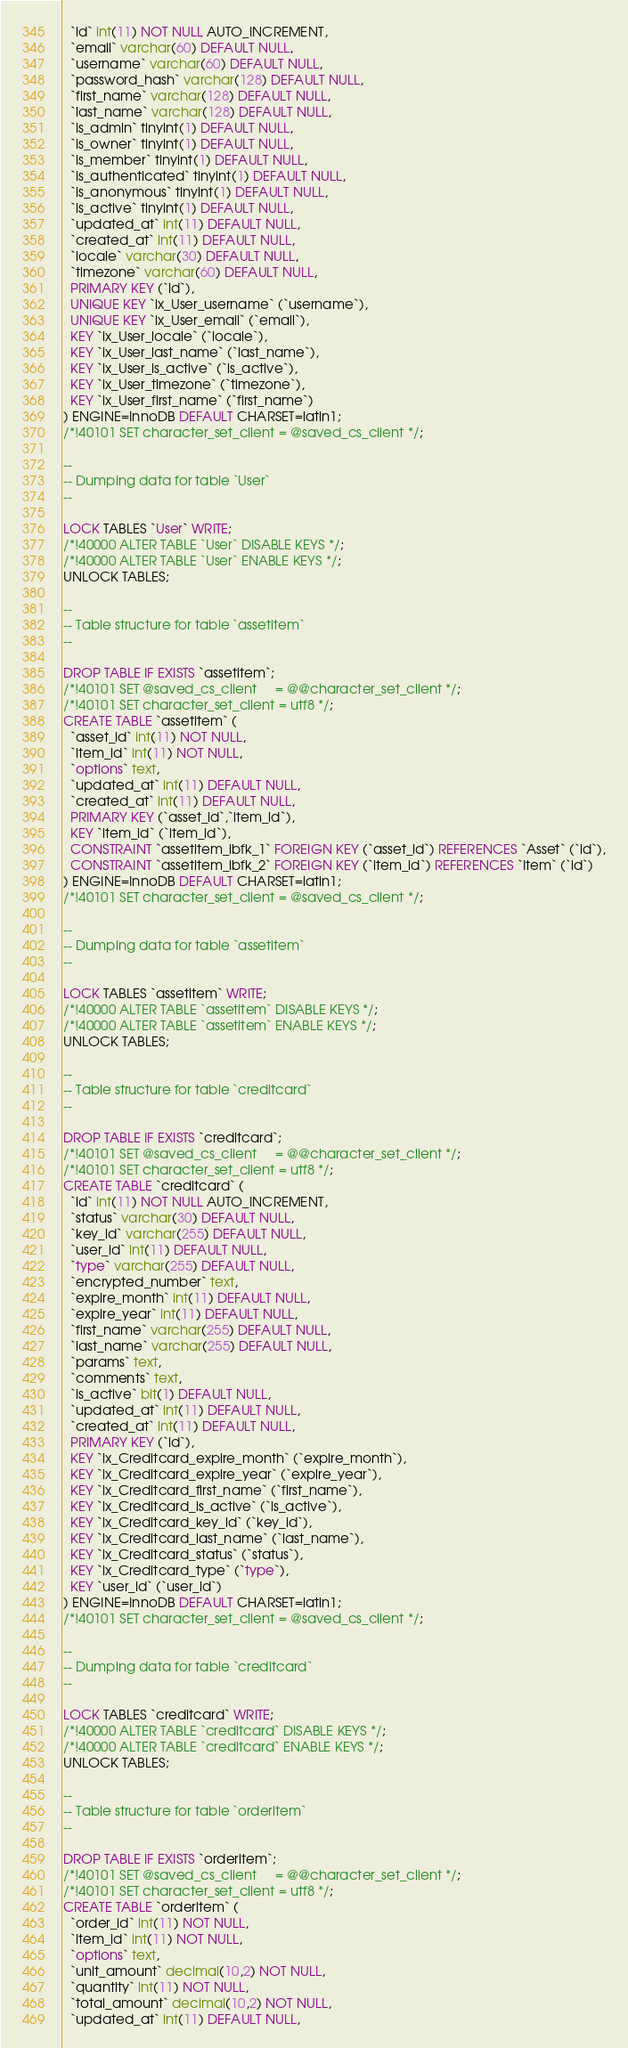Convert code to text. <code><loc_0><loc_0><loc_500><loc_500><_SQL_>  `id` int(11) NOT NULL AUTO_INCREMENT,
  `email` varchar(60) DEFAULT NULL,
  `username` varchar(60) DEFAULT NULL,
  `password_hash` varchar(128) DEFAULT NULL,
  `first_name` varchar(128) DEFAULT NULL,
  `last_name` varchar(128) DEFAULT NULL,
  `is_admin` tinyint(1) DEFAULT NULL,
  `is_owner` tinyint(1) DEFAULT NULL,
  `is_member` tinyint(1) DEFAULT NULL,
  `is_authenticated` tinyint(1) DEFAULT NULL,
  `is_anonymous` tinyint(1) DEFAULT NULL,
  `is_active` tinyint(1) DEFAULT NULL,
  `updated_at` int(11) DEFAULT NULL,
  `created_at` int(11) DEFAULT NULL,
  `locale` varchar(30) DEFAULT NULL,
  `timezone` varchar(60) DEFAULT NULL,
  PRIMARY KEY (`id`),
  UNIQUE KEY `ix_User_username` (`username`),
  UNIQUE KEY `ix_User_email` (`email`),
  KEY `ix_User_locale` (`locale`),
  KEY `ix_User_last_name` (`last_name`),
  KEY `ix_User_is_active` (`is_active`),
  KEY `ix_User_timezone` (`timezone`),
  KEY `ix_User_first_name` (`first_name`)
) ENGINE=InnoDB DEFAULT CHARSET=latin1;
/*!40101 SET character_set_client = @saved_cs_client */;

--
-- Dumping data for table `User`
--

LOCK TABLES `User` WRITE;
/*!40000 ALTER TABLE `User` DISABLE KEYS */;
/*!40000 ALTER TABLE `User` ENABLE KEYS */;
UNLOCK TABLES;

--
-- Table structure for table `assetitem`
--

DROP TABLE IF EXISTS `assetitem`;
/*!40101 SET @saved_cs_client     = @@character_set_client */;
/*!40101 SET character_set_client = utf8 */;
CREATE TABLE `assetitem` (
  `asset_id` int(11) NOT NULL,
  `item_id` int(11) NOT NULL,
  `options` text,
  `updated_at` int(11) DEFAULT NULL,
  `created_at` int(11) DEFAULT NULL,
  PRIMARY KEY (`asset_id`,`item_id`),
  KEY `item_id` (`item_id`),
  CONSTRAINT `assetitem_ibfk_1` FOREIGN KEY (`asset_id`) REFERENCES `Asset` (`id`),
  CONSTRAINT `assetitem_ibfk_2` FOREIGN KEY (`item_id`) REFERENCES `Item` (`id`)
) ENGINE=InnoDB DEFAULT CHARSET=latin1;
/*!40101 SET character_set_client = @saved_cs_client */;

--
-- Dumping data for table `assetitem`
--

LOCK TABLES `assetitem` WRITE;
/*!40000 ALTER TABLE `assetitem` DISABLE KEYS */;
/*!40000 ALTER TABLE `assetitem` ENABLE KEYS */;
UNLOCK TABLES;

--
-- Table structure for table `creditcard`
--

DROP TABLE IF EXISTS `creditcard`;
/*!40101 SET @saved_cs_client     = @@character_set_client */;
/*!40101 SET character_set_client = utf8 */;
CREATE TABLE `creditcard` (
  `id` int(11) NOT NULL AUTO_INCREMENT,
  `status` varchar(30) DEFAULT NULL,
  `key_id` varchar(255) DEFAULT NULL,
  `user_id` int(11) DEFAULT NULL,
  `type` varchar(255) DEFAULT NULL,
  `encrypted_number` text,
  `expire_month` int(11) DEFAULT NULL,
  `expire_year` int(11) DEFAULT NULL,
  `first_name` varchar(255) DEFAULT NULL,
  `last_name` varchar(255) DEFAULT NULL,
  `params` text,
  `comments` text,
  `is_active` bit(1) DEFAULT NULL,
  `updated_at` int(11) DEFAULT NULL,
  `created_at` int(11) DEFAULT NULL,
  PRIMARY KEY (`id`),
  KEY `ix_Creditcard_expire_month` (`expire_month`),
  KEY `ix_Creditcard_expire_year` (`expire_year`),
  KEY `ix_Creditcard_first_name` (`first_name`),
  KEY `ix_Creditcard_is_active` (`is_active`),
  KEY `ix_Creditcard_key_id` (`key_id`),
  KEY `ix_Creditcard_last_name` (`last_name`),
  KEY `ix_Creditcard_status` (`status`),
  KEY `ix_Creditcard_type` (`type`),
  KEY `user_id` (`user_id`)
) ENGINE=InnoDB DEFAULT CHARSET=latin1;
/*!40101 SET character_set_client = @saved_cs_client */;

--
-- Dumping data for table `creditcard`
--

LOCK TABLES `creditcard` WRITE;
/*!40000 ALTER TABLE `creditcard` DISABLE KEYS */;
/*!40000 ALTER TABLE `creditcard` ENABLE KEYS */;
UNLOCK TABLES;

--
-- Table structure for table `orderitem`
--

DROP TABLE IF EXISTS `orderitem`;
/*!40101 SET @saved_cs_client     = @@character_set_client */;
/*!40101 SET character_set_client = utf8 */;
CREATE TABLE `orderitem` (
  `order_id` int(11) NOT NULL,
  `item_id` int(11) NOT NULL,
  `options` text,
  `unit_amount` decimal(10,2) NOT NULL,
  `quantity` int(11) NOT NULL,
  `total_amount` decimal(10,2) NOT NULL,
  `updated_at` int(11) DEFAULT NULL,</code> 